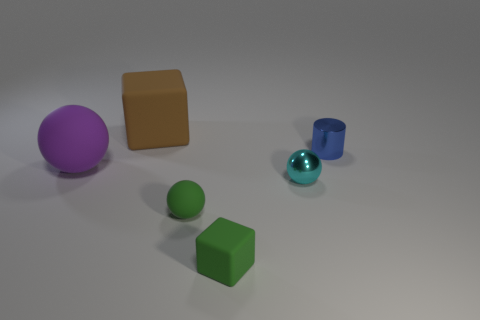Subtract all cyan cylinders. Subtract all purple blocks. How many cylinders are left? 1 Subtract all brown cubes. How many cyan spheres are left? 1 Add 3 purples. How many cyans exist? 0 Subtract all small cyan balls. Subtract all purple matte objects. How many objects are left? 4 Add 3 large brown objects. How many large brown objects are left? 4 Add 5 big purple things. How many big purple things exist? 6 Add 1 small green balls. How many objects exist? 7 Subtract all green balls. How many balls are left? 2 Subtract all small cyan shiny balls. How many balls are left? 2 Subtract 0 red balls. How many objects are left? 6 